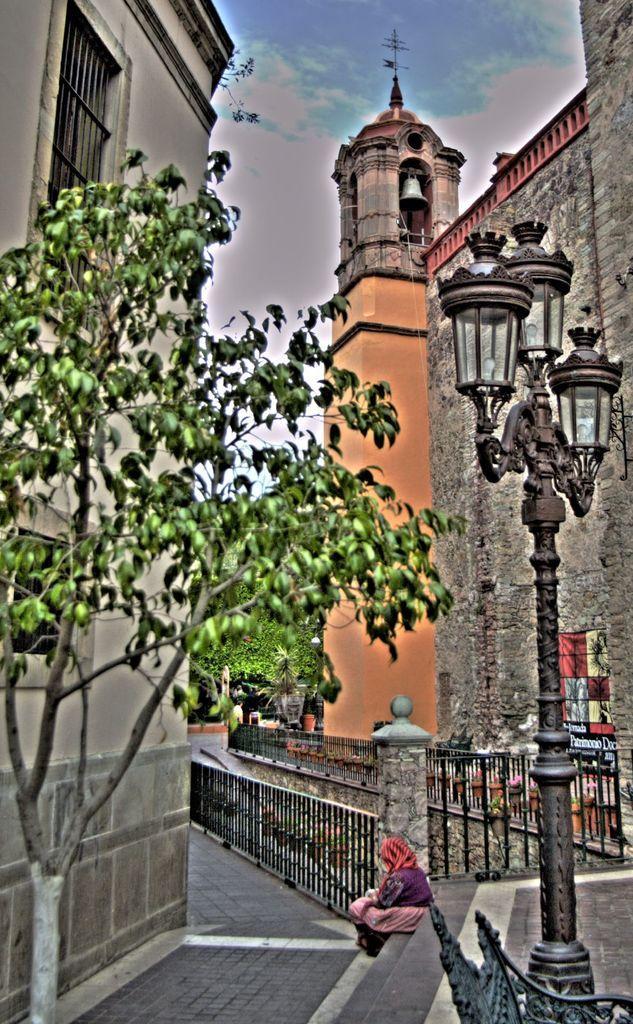Please provide a concise description of this image. On the left side, there are a tree, a road and a building which is having windows. On the right side, there is a person sitting on a step, there are three lights attached to a pole and a fence. In the background, there is a building, a tower, trees and there are clouds in the sky. 